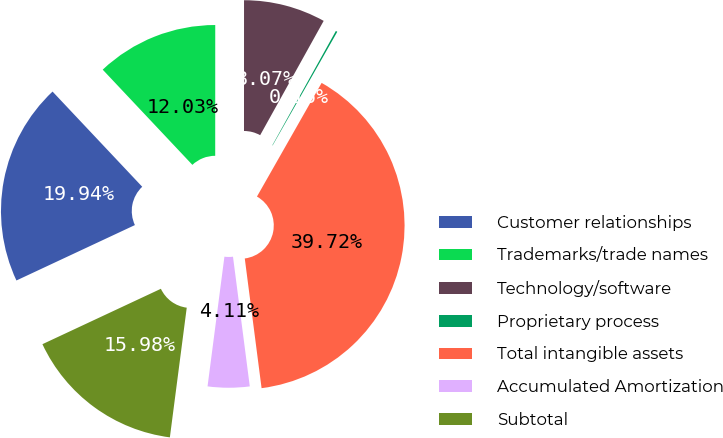Convert chart to OTSL. <chart><loc_0><loc_0><loc_500><loc_500><pie_chart><fcel>Customer relationships<fcel>Trademarks/trade names<fcel>Technology/software<fcel>Proprietary process<fcel>Total intangible assets<fcel>Accumulated Amortization<fcel>Subtotal<nl><fcel>19.94%<fcel>12.03%<fcel>8.07%<fcel>0.16%<fcel>39.72%<fcel>4.11%<fcel>15.98%<nl></chart> 